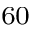<formula> <loc_0><loc_0><loc_500><loc_500>^ { 6 0 }</formula> 